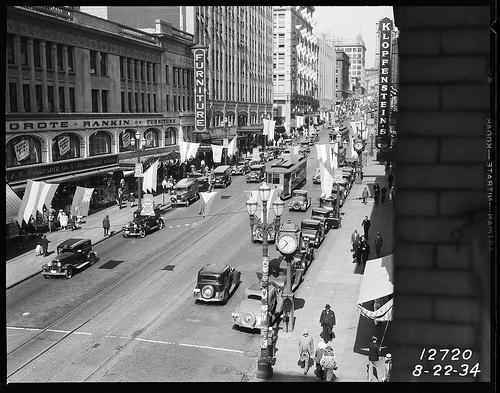What is in the street?
Select the accurate response from the four choices given to answer the question.
Options: Cows, cats, cars, tank. Cars. 